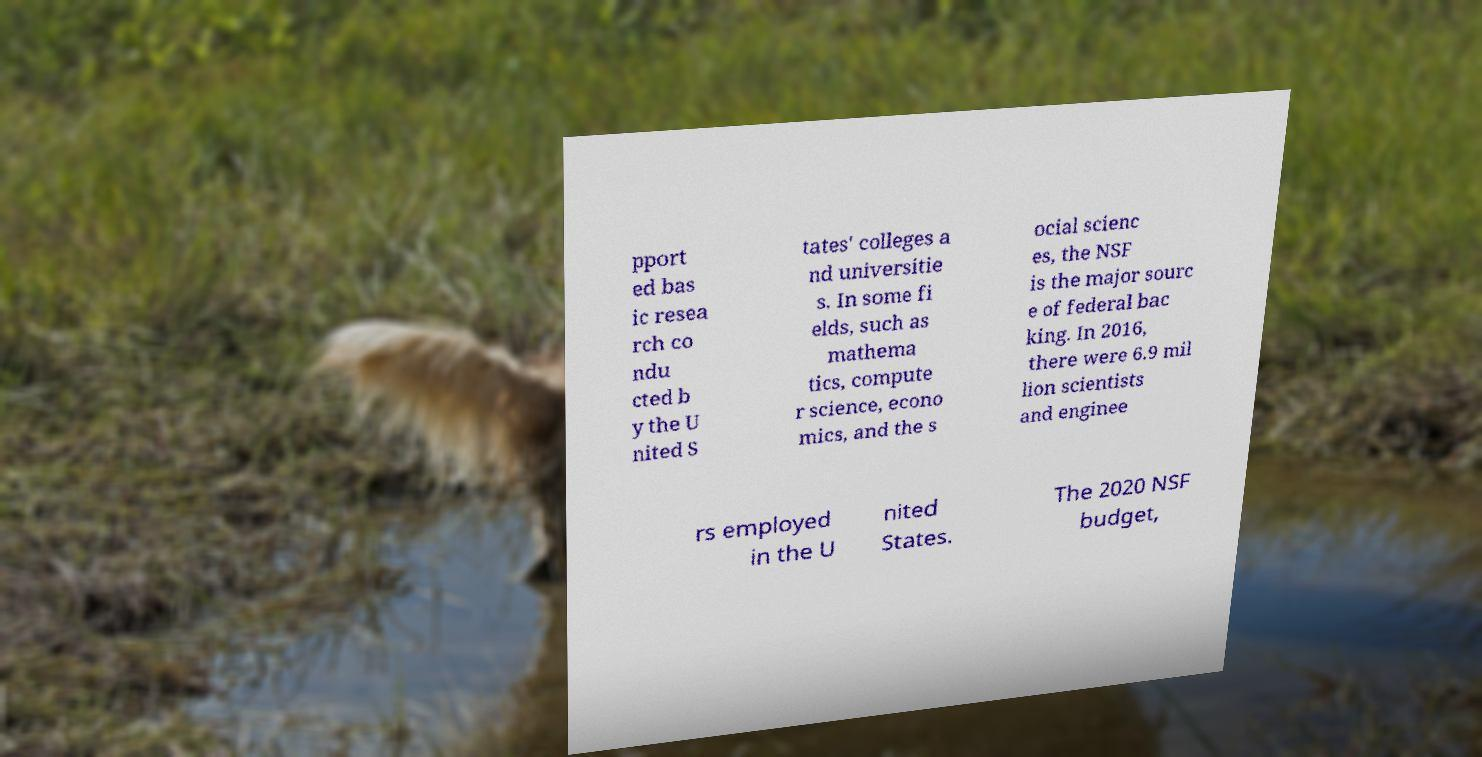Could you extract and type out the text from this image? pport ed bas ic resea rch co ndu cted b y the U nited S tates' colleges a nd universitie s. In some fi elds, such as mathema tics, compute r science, econo mics, and the s ocial scienc es, the NSF is the major sourc e of federal bac king. In 2016, there were 6.9 mil lion scientists and enginee rs employed in the U nited States. The 2020 NSF budget, 